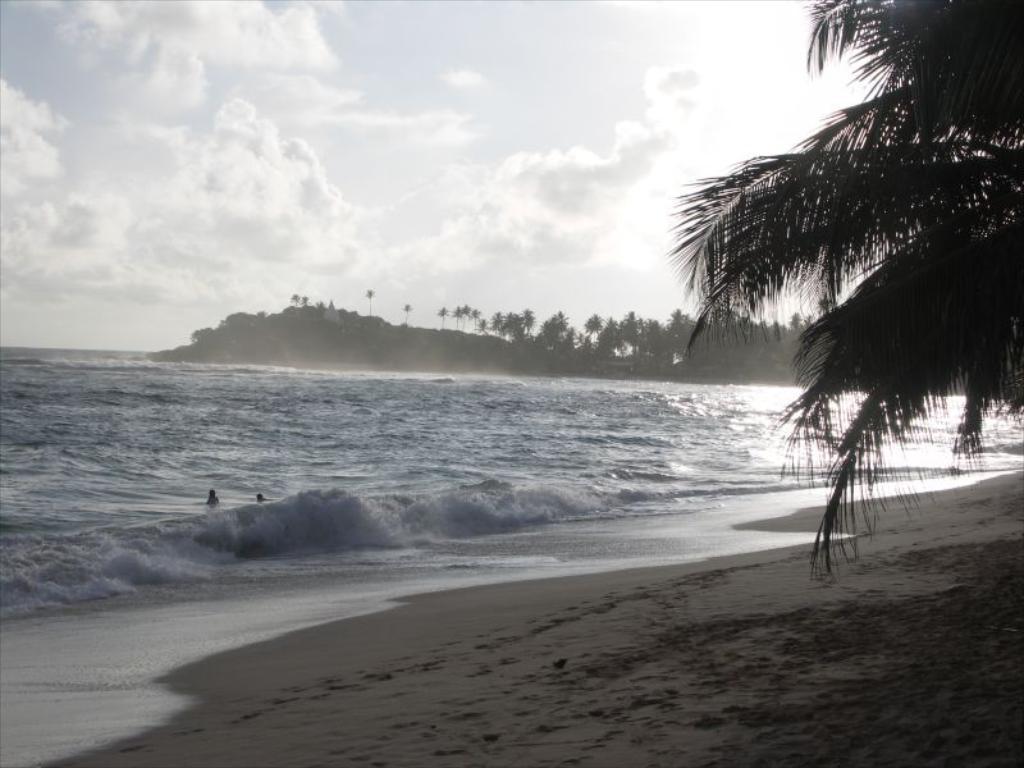Could you give a brief overview of what you see in this image? In this image we can see a sea shore. Also there are waves. And there are two persons in the water. On the right side we can see leaves of coconut trees. In the background there are trees and sky with clouds. 